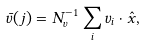Convert formula to latex. <formula><loc_0><loc_0><loc_500><loc_500>\bar { v } ( j ) = N _ { v } ^ { - 1 } \sum _ { i } v _ { i } \cdot \hat { x } ,</formula> 